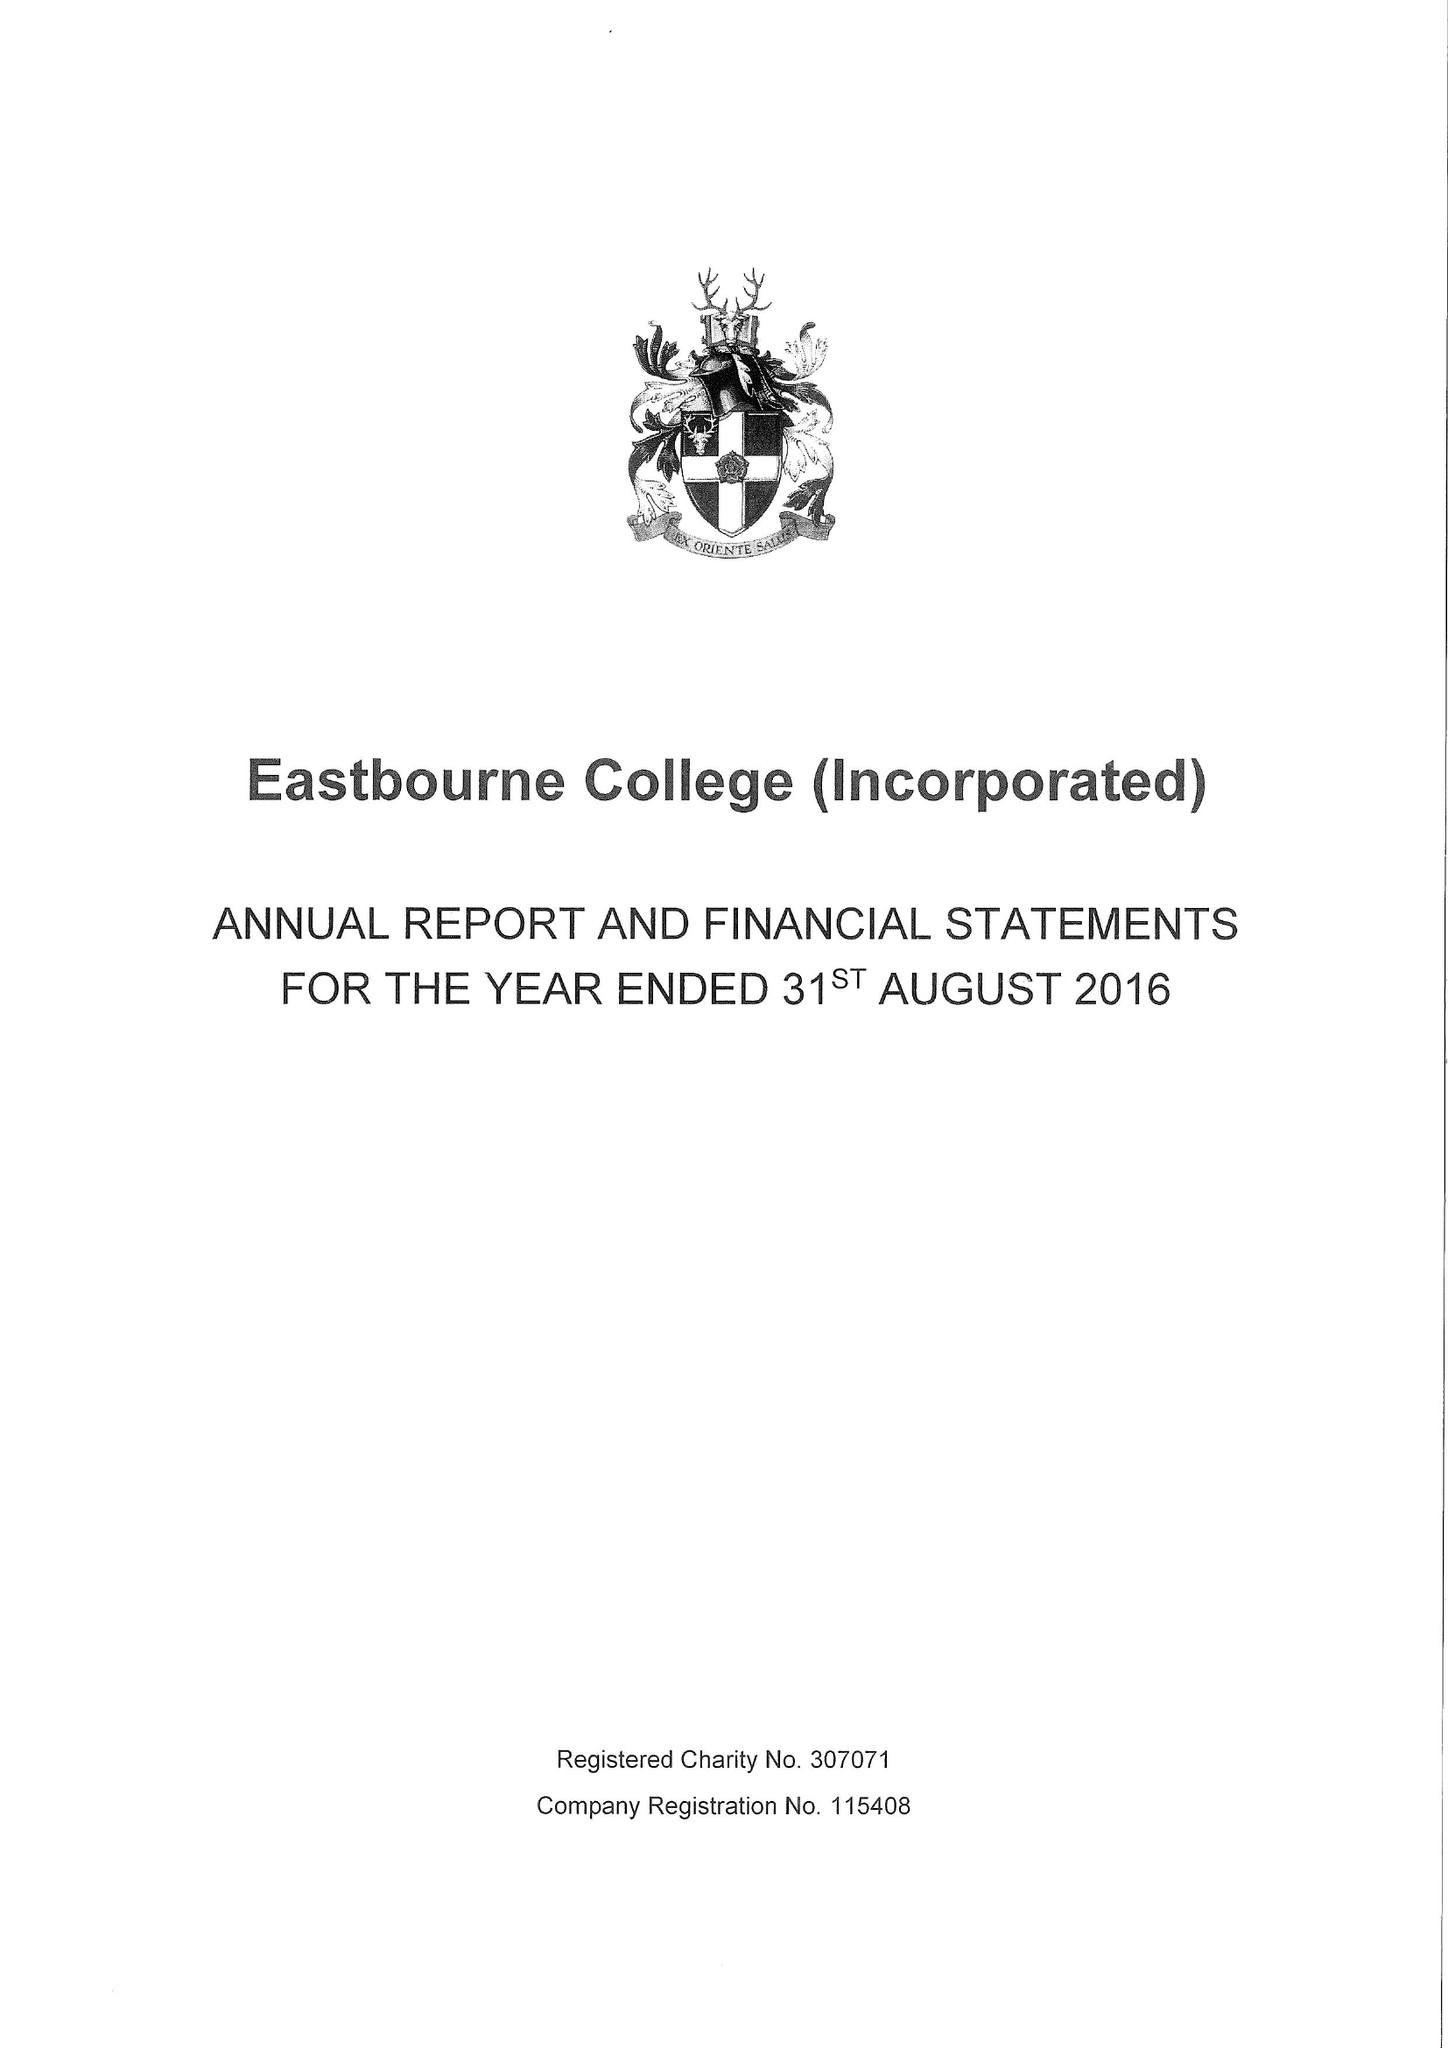What is the value for the address__postcode?
Answer the question using a single word or phrase. BN21 4JY 